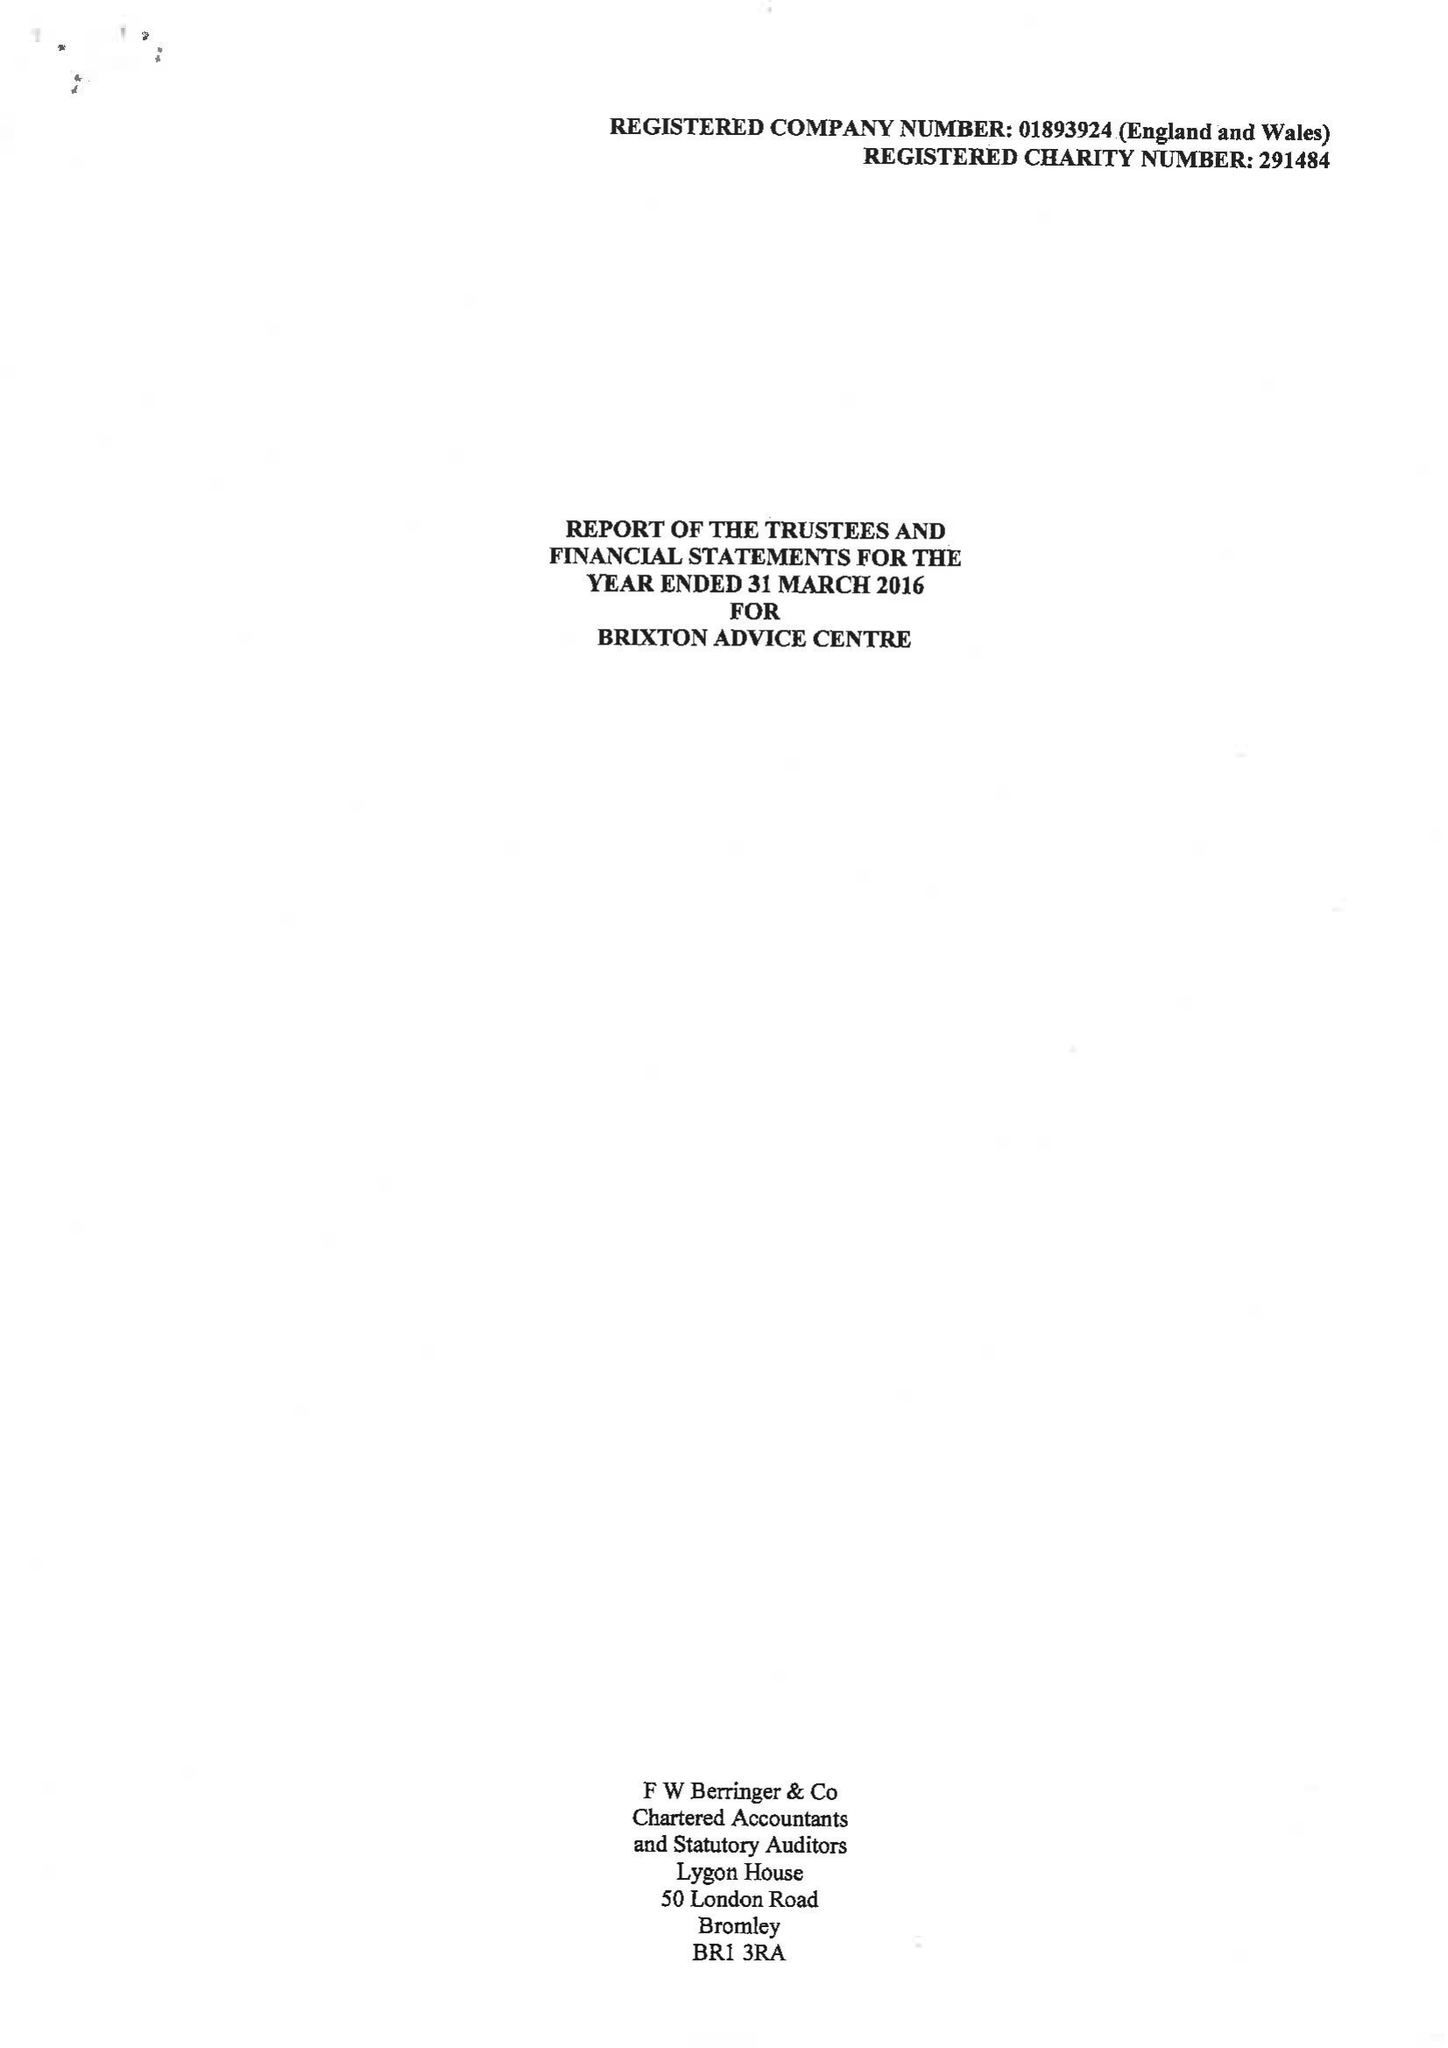What is the value for the income_annually_in_british_pounds?
Answer the question using a single word or phrase. 499691.00 